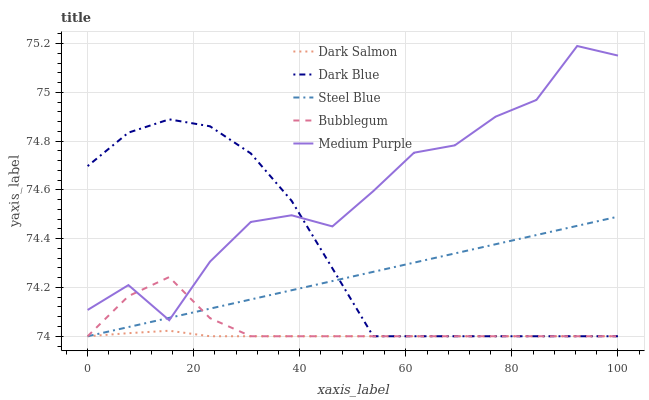Does Dark Salmon have the minimum area under the curve?
Answer yes or no. Yes. Does Medium Purple have the maximum area under the curve?
Answer yes or no. Yes. Does Dark Blue have the minimum area under the curve?
Answer yes or no. No. Does Dark Blue have the maximum area under the curve?
Answer yes or no. No. Is Steel Blue the smoothest?
Answer yes or no. Yes. Is Medium Purple the roughest?
Answer yes or no. Yes. Is Dark Blue the smoothest?
Answer yes or no. No. Is Dark Blue the roughest?
Answer yes or no. No. Does Dark Blue have the lowest value?
Answer yes or no. Yes. Does Medium Purple have the highest value?
Answer yes or no. Yes. Does Dark Blue have the highest value?
Answer yes or no. No. Is Dark Salmon less than Medium Purple?
Answer yes or no. Yes. Is Medium Purple greater than Dark Salmon?
Answer yes or no. Yes. Does Dark Blue intersect Steel Blue?
Answer yes or no. Yes. Is Dark Blue less than Steel Blue?
Answer yes or no. No. Is Dark Blue greater than Steel Blue?
Answer yes or no. No. Does Dark Salmon intersect Medium Purple?
Answer yes or no. No. 